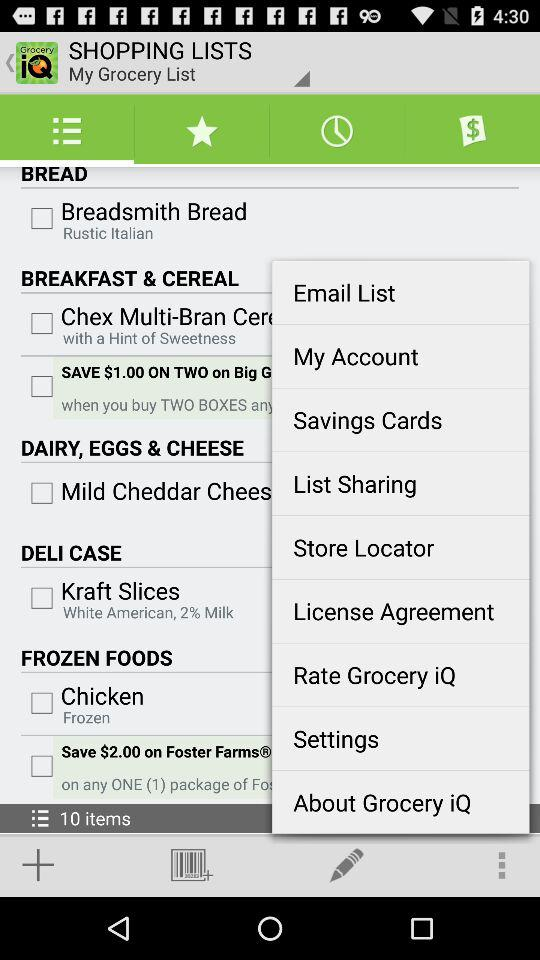What type of bread is "Breadsmith Bread"? The type of bread is "Rustic Italian". 